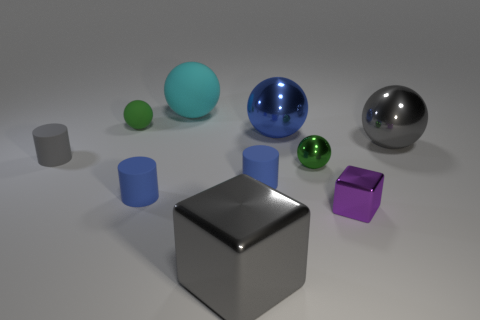How many green objects are matte objects or tiny metal balls?
Ensure brevity in your answer.  2. How many other things are made of the same material as the big gray ball?
Keep it short and to the point. 4. Is the shape of the small green object that is on the left side of the small green metallic ball the same as  the small purple object?
Make the answer very short. No. Are there any large cyan balls?
Make the answer very short. Yes. Is there any other thing that has the same shape as the tiny purple thing?
Make the answer very short. Yes. Are there more green metal things behind the blue sphere than gray metallic cubes?
Make the answer very short. No. There is a tiny green metal object; are there any blue matte things in front of it?
Offer a terse response. Yes. Does the gray shiny sphere have the same size as the purple metal block?
Make the answer very short. No. The cyan thing that is the same shape as the tiny green rubber object is what size?
Offer a very short reply. Large. There is a small ball that is on the right side of the large gray object in front of the tiny green metal ball; what is its material?
Offer a very short reply. Metal. 